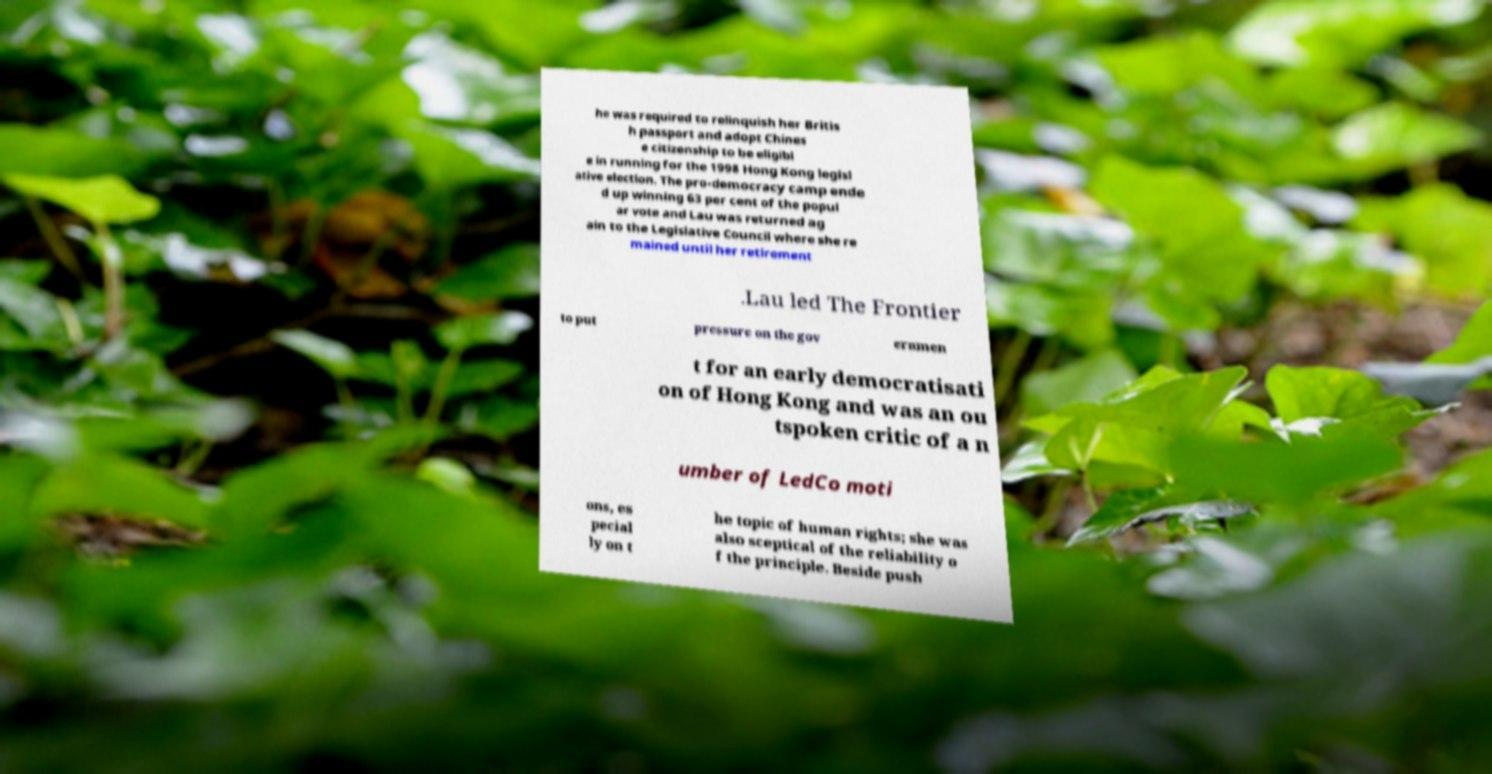I need the written content from this picture converted into text. Can you do that? he was required to relinquish her Britis h passport and adopt Chines e citizenship to be eligibl e in running for the 1998 Hong Kong legisl ative election. The pro-democracy camp ende d up winning 63 per cent of the popul ar vote and Lau was returned ag ain to the Legislative Council where she re mained until her retirement .Lau led The Frontier to put pressure on the gov ernmen t for an early democratisati on of Hong Kong and was an ou tspoken critic of a n umber of LedCo moti ons, es pecial ly on t he topic of human rights; she was also sceptical of the reliability o f the principle. Beside push 